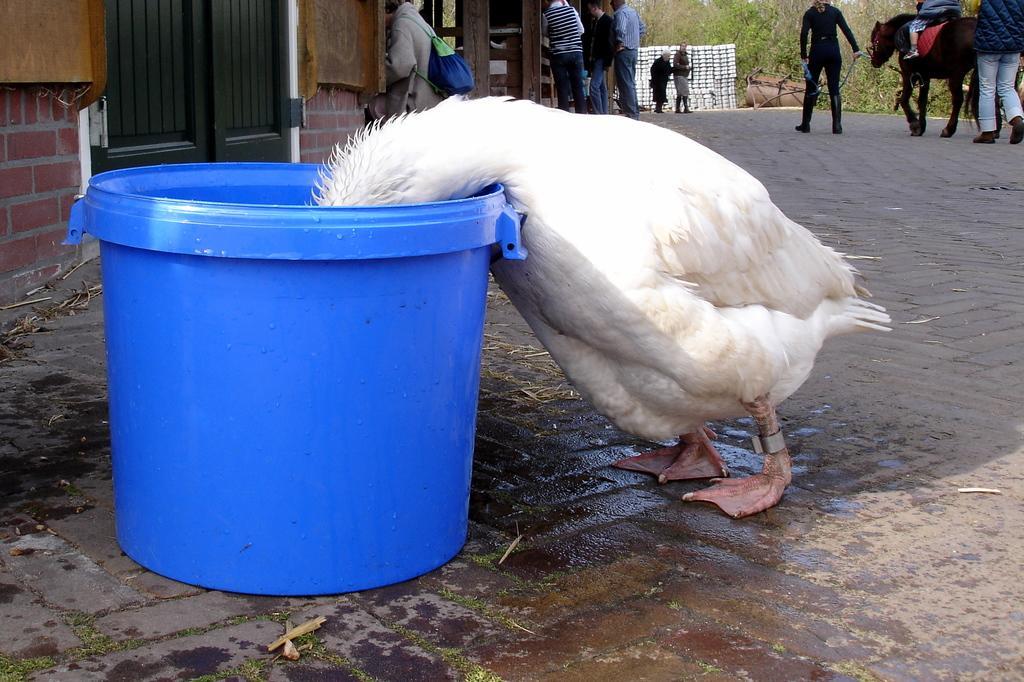Describe this image in one or two sentences. In this image, we can see people wearing clothes. There is a duck and bucket in the middle of the image. There is a door in the top left of the image. There are some trees and plants in the top right of the image. There is a person sitting on a horse. 